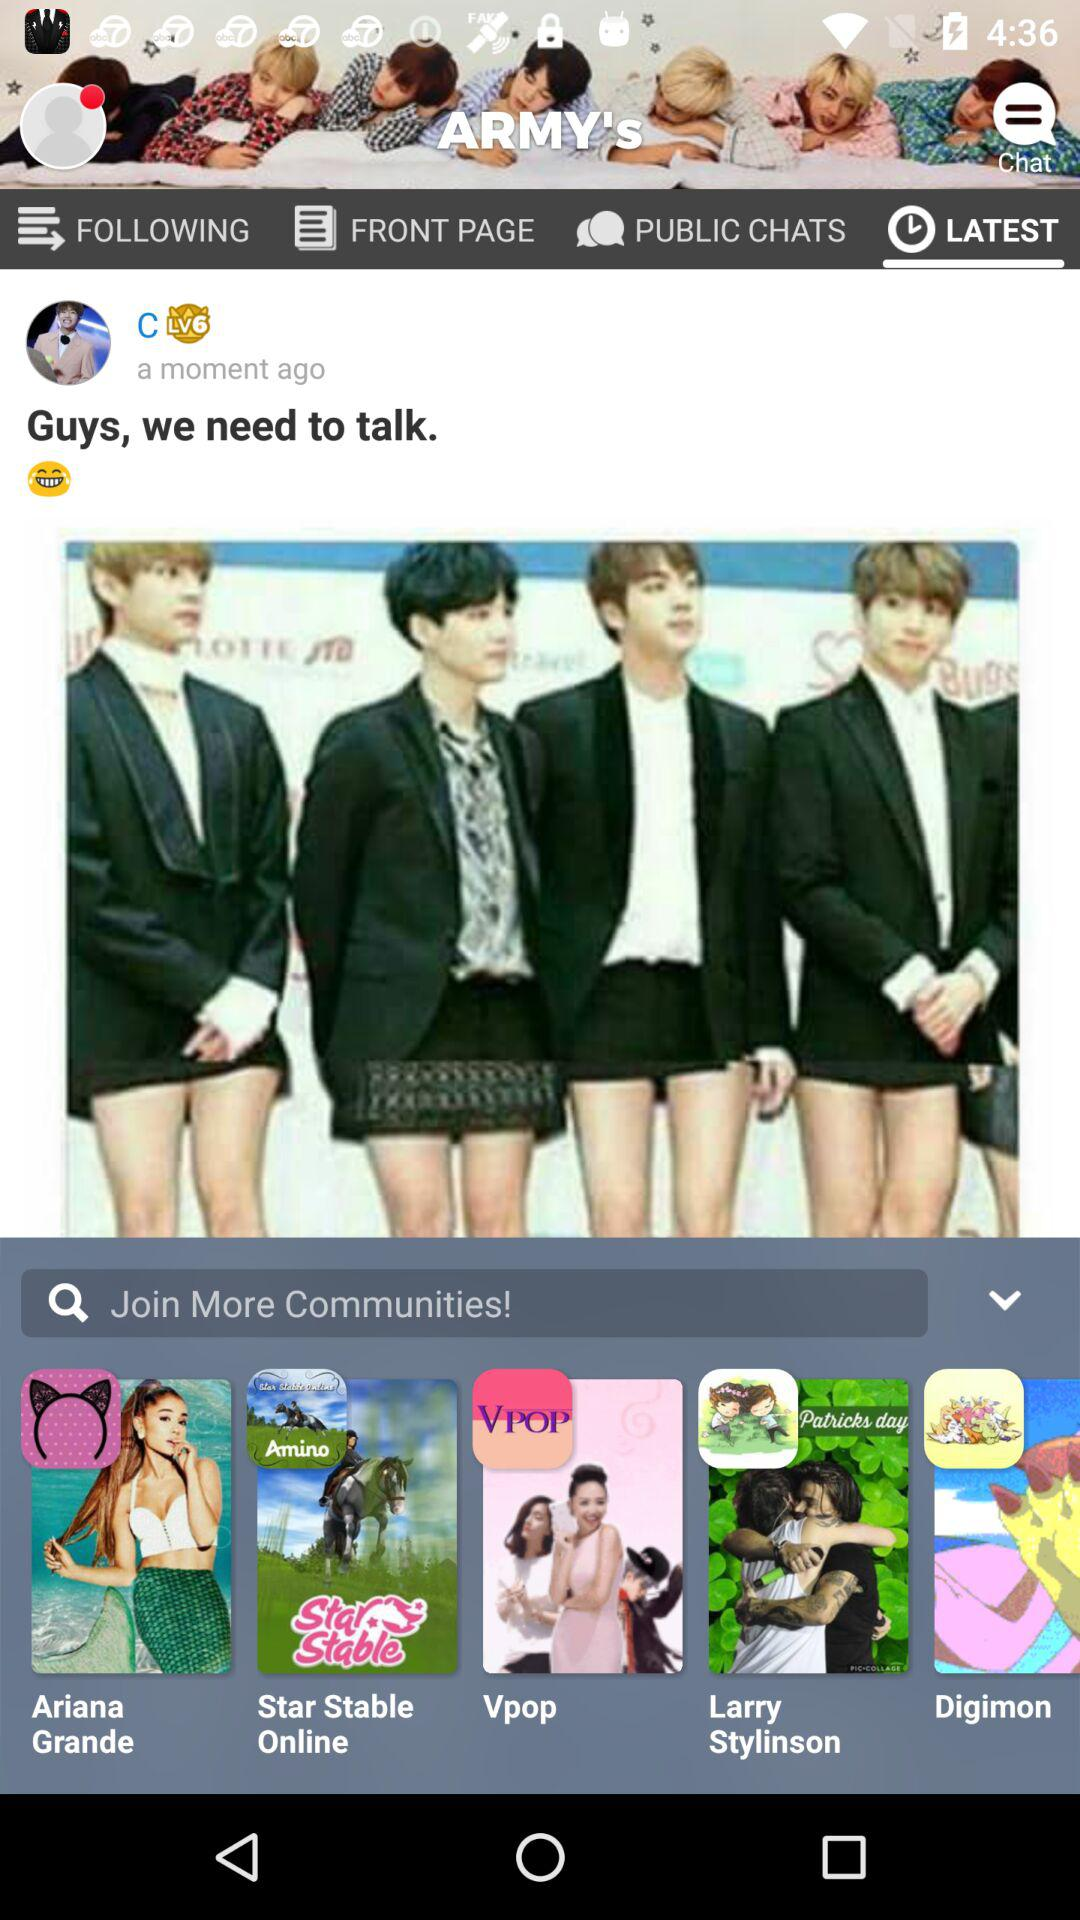Which tab is open? The open tab is "LATEST". 